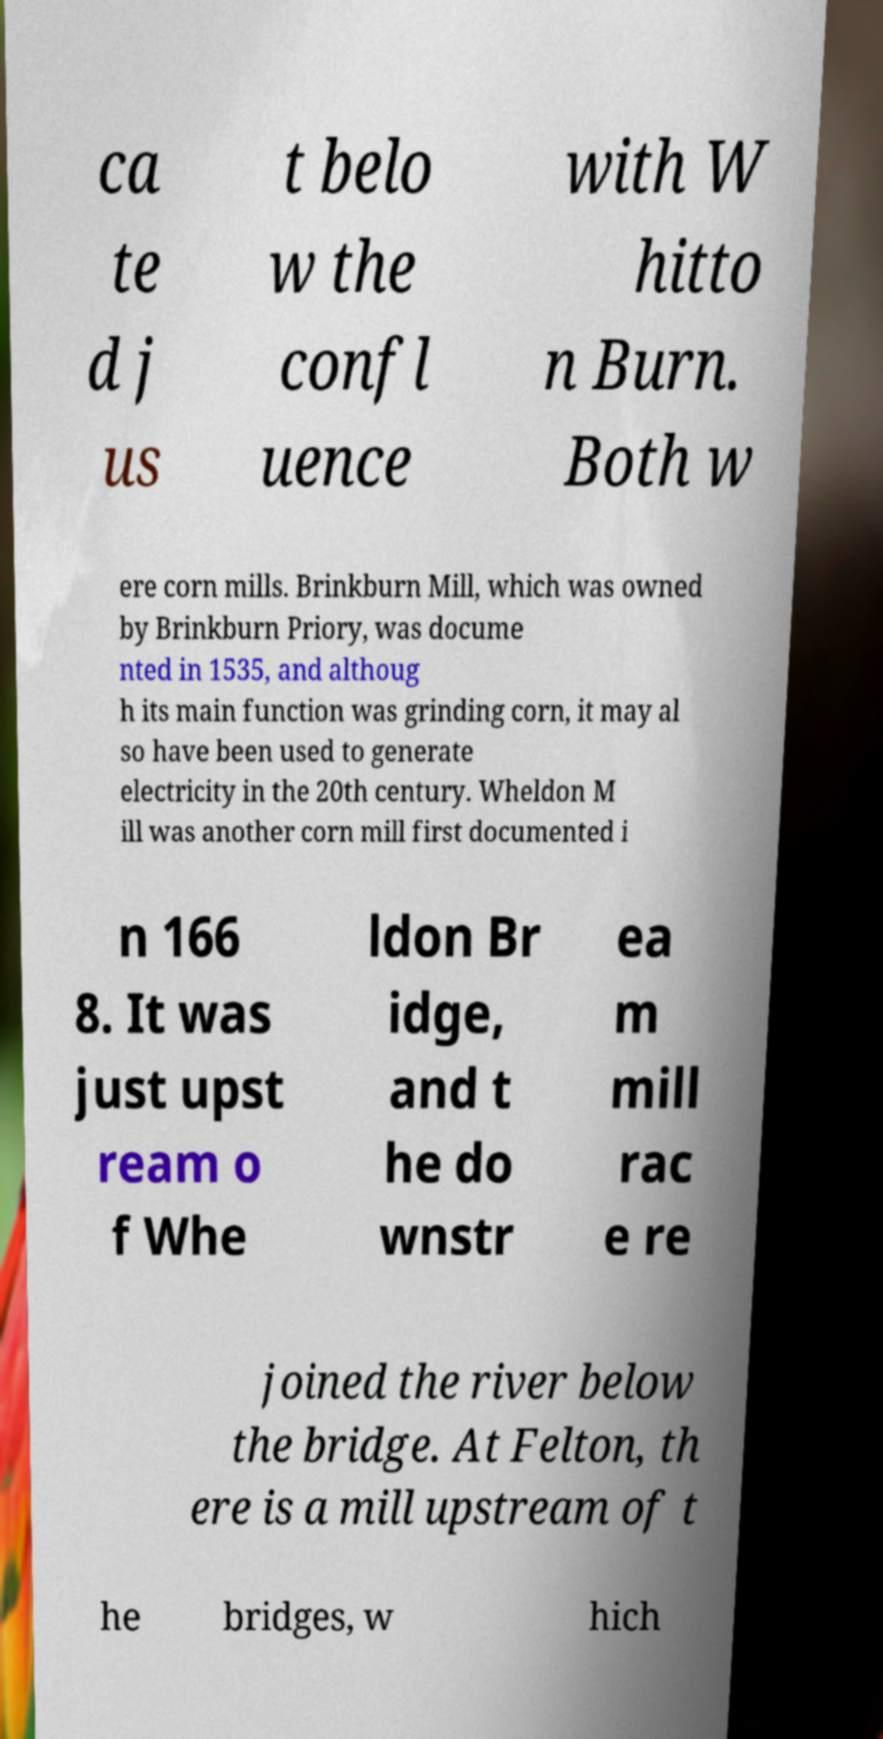What messages or text are displayed in this image? I need them in a readable, typed format. ca te d j us t belo w the confl uence with W hitto n Burn. Both w ere corn mills. Brinkburn Mill, which was owned by Brinkburn Priory, was docume nted in 1535, and althoug h its main function was grinding corn, it may al so have been used to generate electricity in the 20th century. Wheldon M ill was another corn mill first documented i n 166 8. It was just upst ream o f Whe ldon Br idge, and t he do wnstr ea m mill rac e re joined the river below the bridge. At Felton, th ere is a mill upstream of t he bridges, w hich 